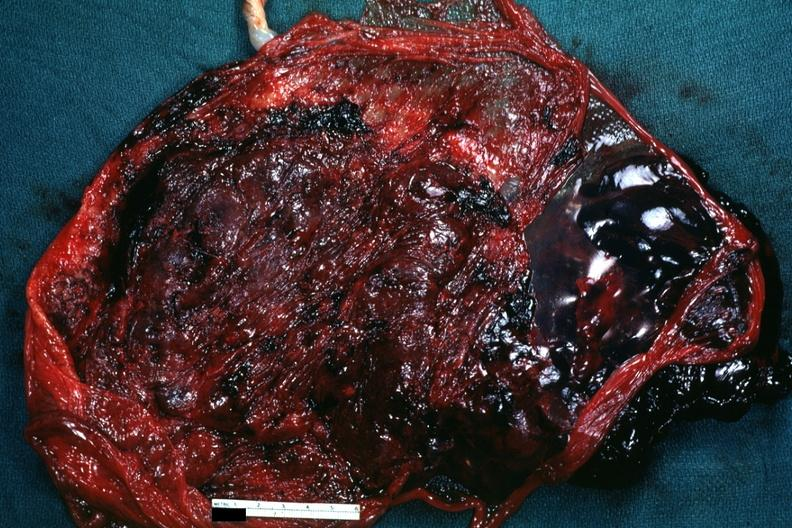does fat necrosis show maternal surface with blood clot?
Answer the question using a single word or phrase. No 